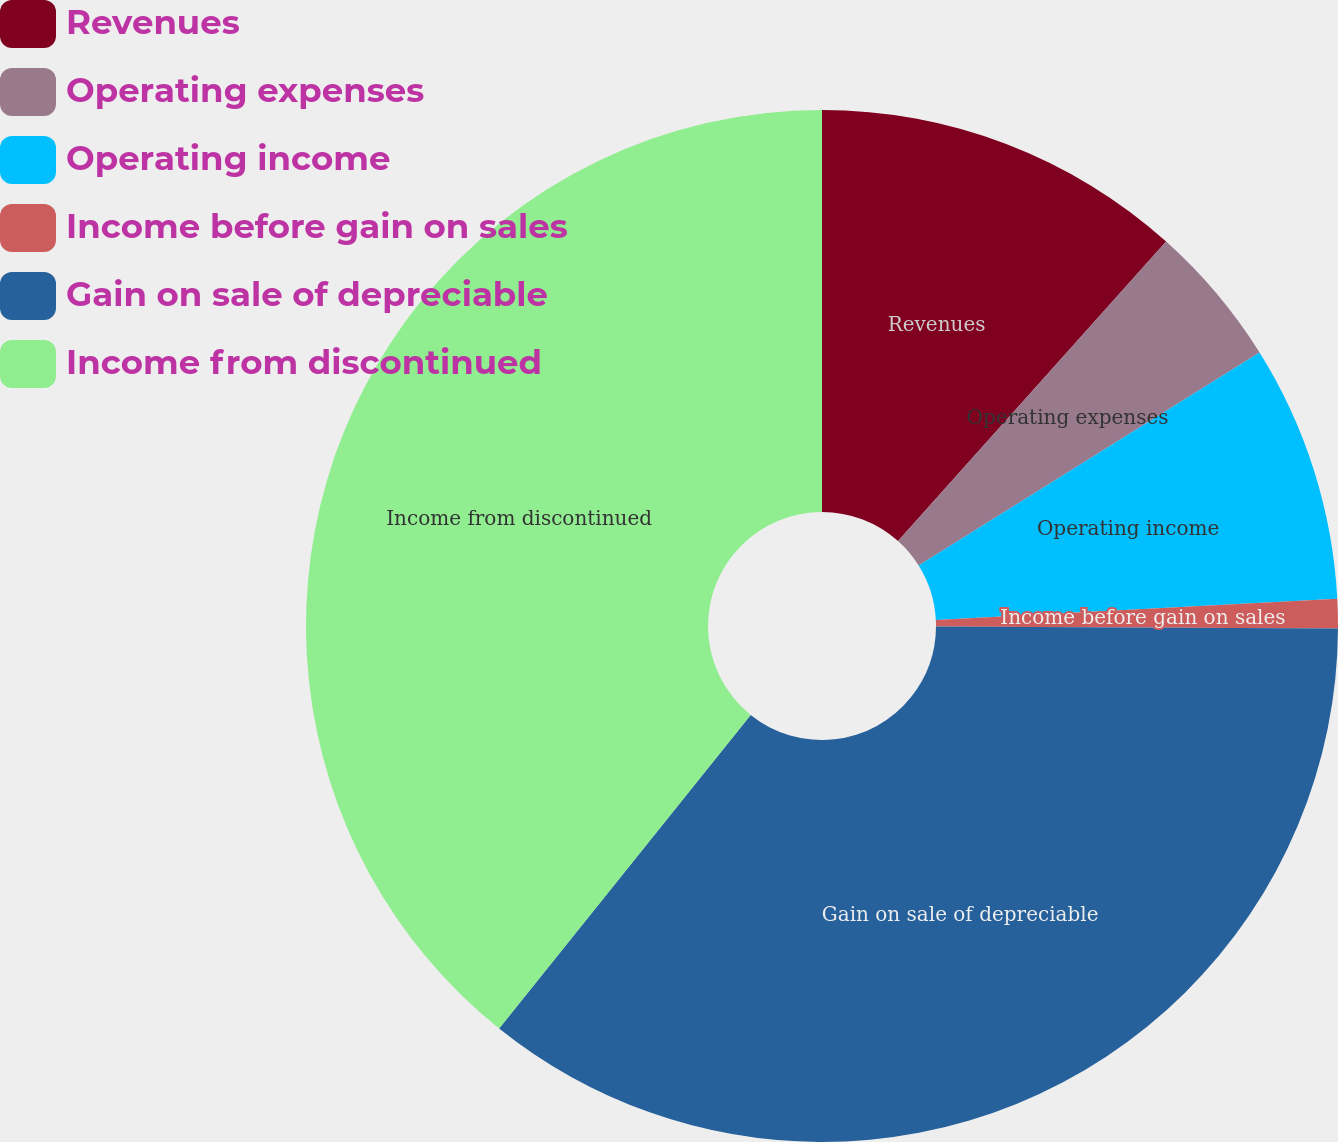Convert chart. <chart><loc_0><loc_0><loc_500><loc_500><pie_chart><fcel>Revenues<fcel>Operating expenses<fcel>Operating income<fcel>Income before gain on sales<fcel>Gain on sale of depreciable<fcel>Income from discontinued<nl><fcel>11.62%<fcel>4.49%<fcel>8.05%<fcel>0.92%<fcel>35.68%<fcel>39.24%<nl></chart> 